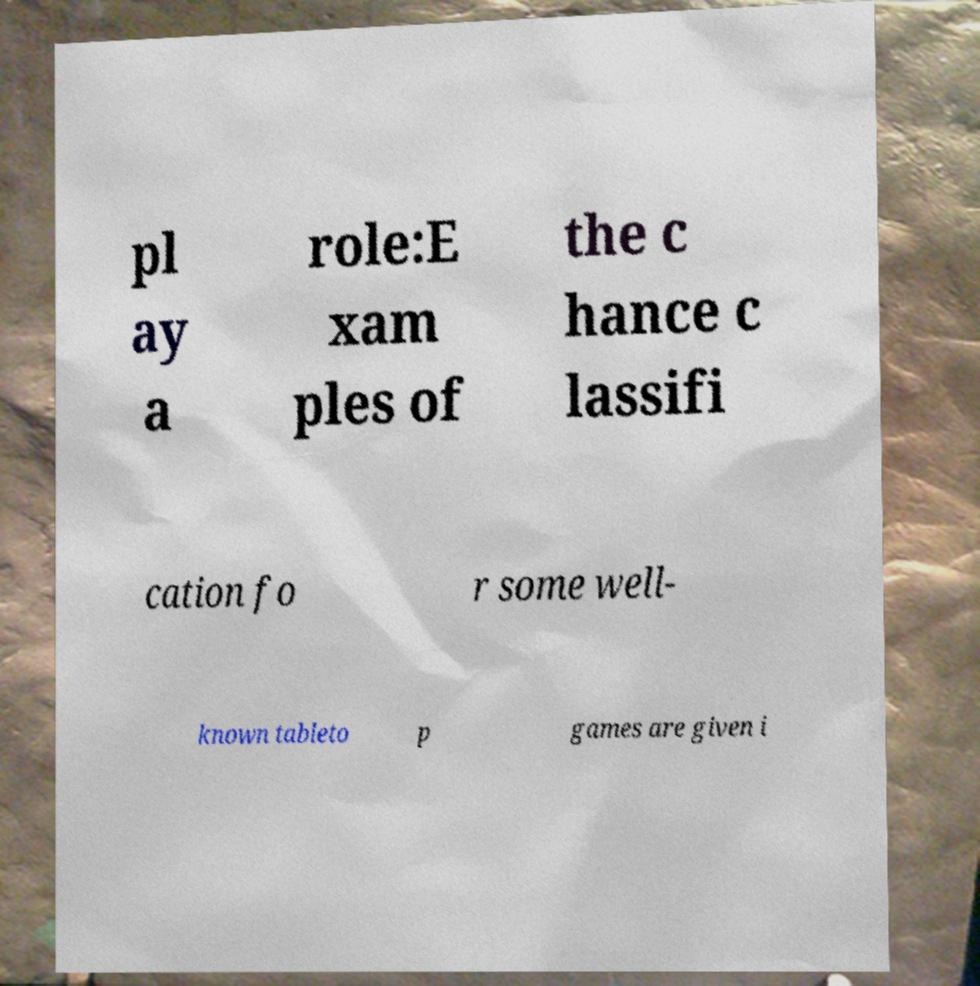What messages or text are displayed in this image? I need them in a readable, typed format. pl ay a role:E xam ples of the c hance c lassifi cation fo r some well- known tableto p games are given i 